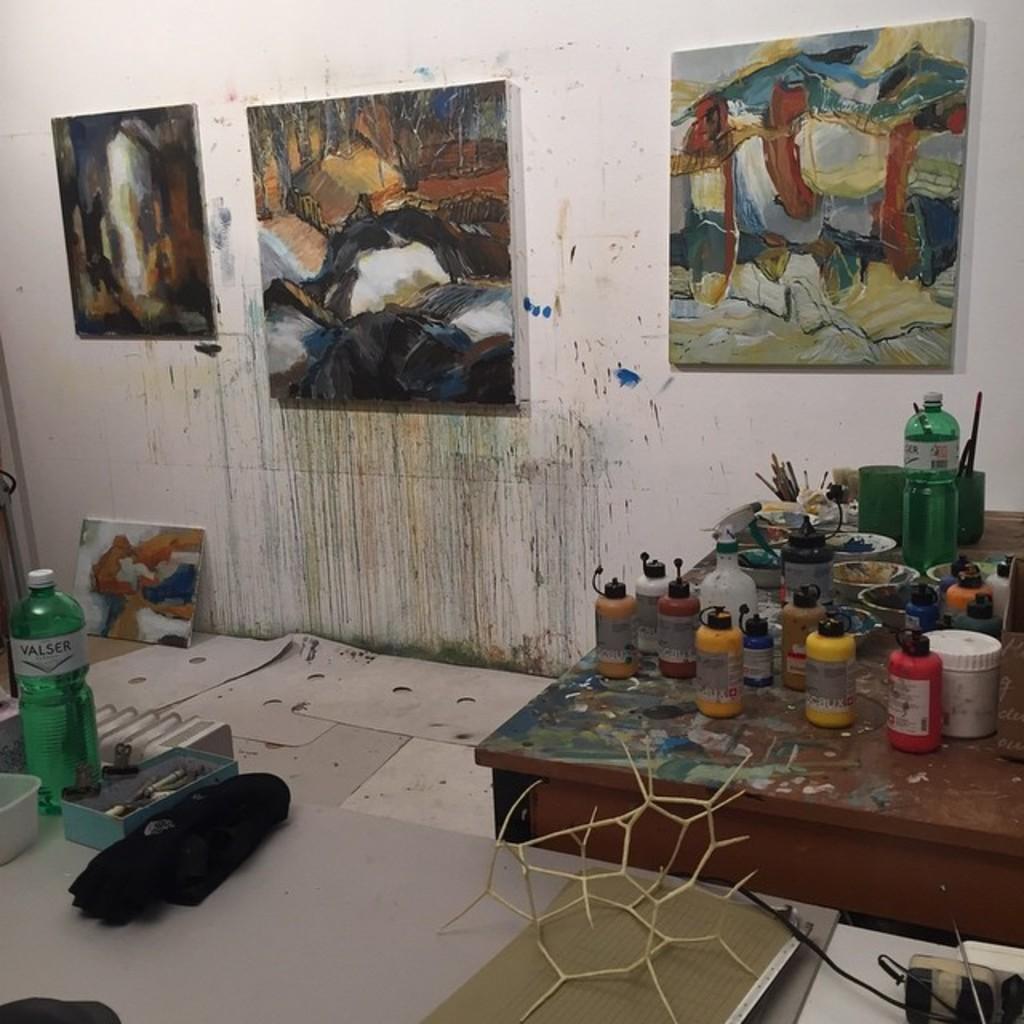Please provide a concise description of this image. There are four plants in this room, three are on the wall and the fourth is on the left side of the image and at the bottom left of the image there is a water bottle and a box. At the right side of the image there is a table on which there are different color paint bottles and paint brushes and a water bottle and at the right side of the image there is a object and the wall is of tiles. 